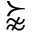<formula> <loc_0><loc_0><loc_500><loc_500>\succnapprox</formula> 